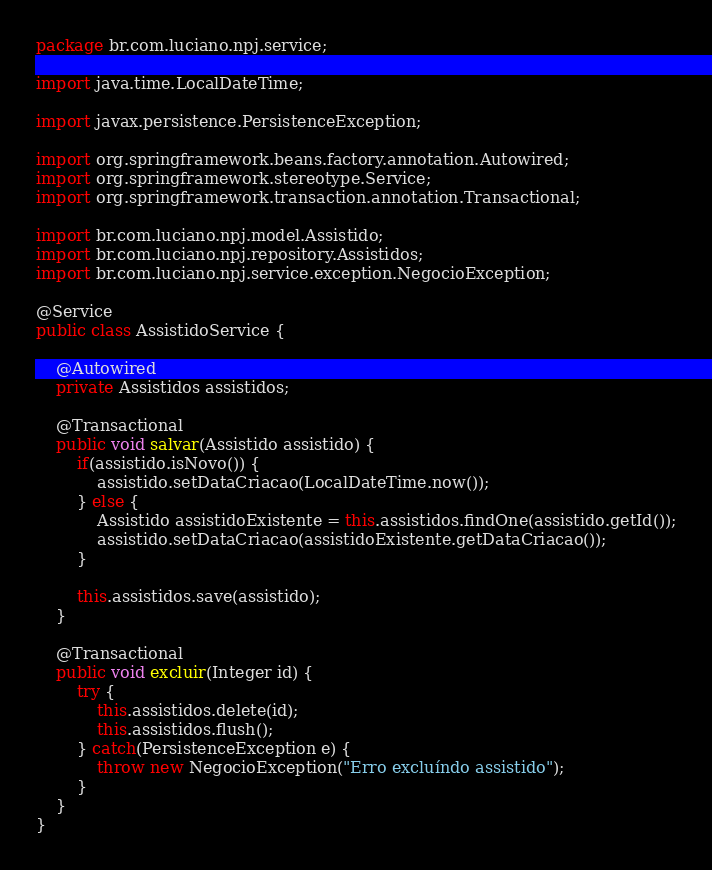<code> <loc_0><loc_0><loc_500><loc_500><_Java_>package br.com.luciano.npj.service;

import java.time.LocalDateTime;

import javax.persistence.PersistenceException;

import org.springframework.beans.factory.annotation.Autowired;
import org.springframework.stereotype.Service;
import org.springframework.transaction.annotation.Transactional;

import br.com.luciano.npj.model.Assistido;
import br.com.luciano.npj.repository.Assistidos;
import br.com.luciano.npj.service.exception.NegocioException;

@Service
public class AssistidoService {
	
	@Autowired
	private Assistidos assistidos;
	
	@Transactional
	public void salvar(Assistido assistido) {
		if(assistido.isNovo()) {
			assistido.setDataCriacao(LocalDateTime.now());
		} else {
			Assistido assistidoExistente = this.assistidos.findOne(assistido.getId());
			assistido.setDataCriacao(assistidoExistente.getDataCriacao());
		}
		
		this.assistidos.save(assistido);
	}

	@Transactional
	public void excluir(Integer id) {
		try {
			this.assistidos.delete(id);
			this.assistidos.flush();
		} catch(PersistenceException e) {
			throw new NegocioException("Erro excluíndo assistido");
		}
	}
}
</code> 